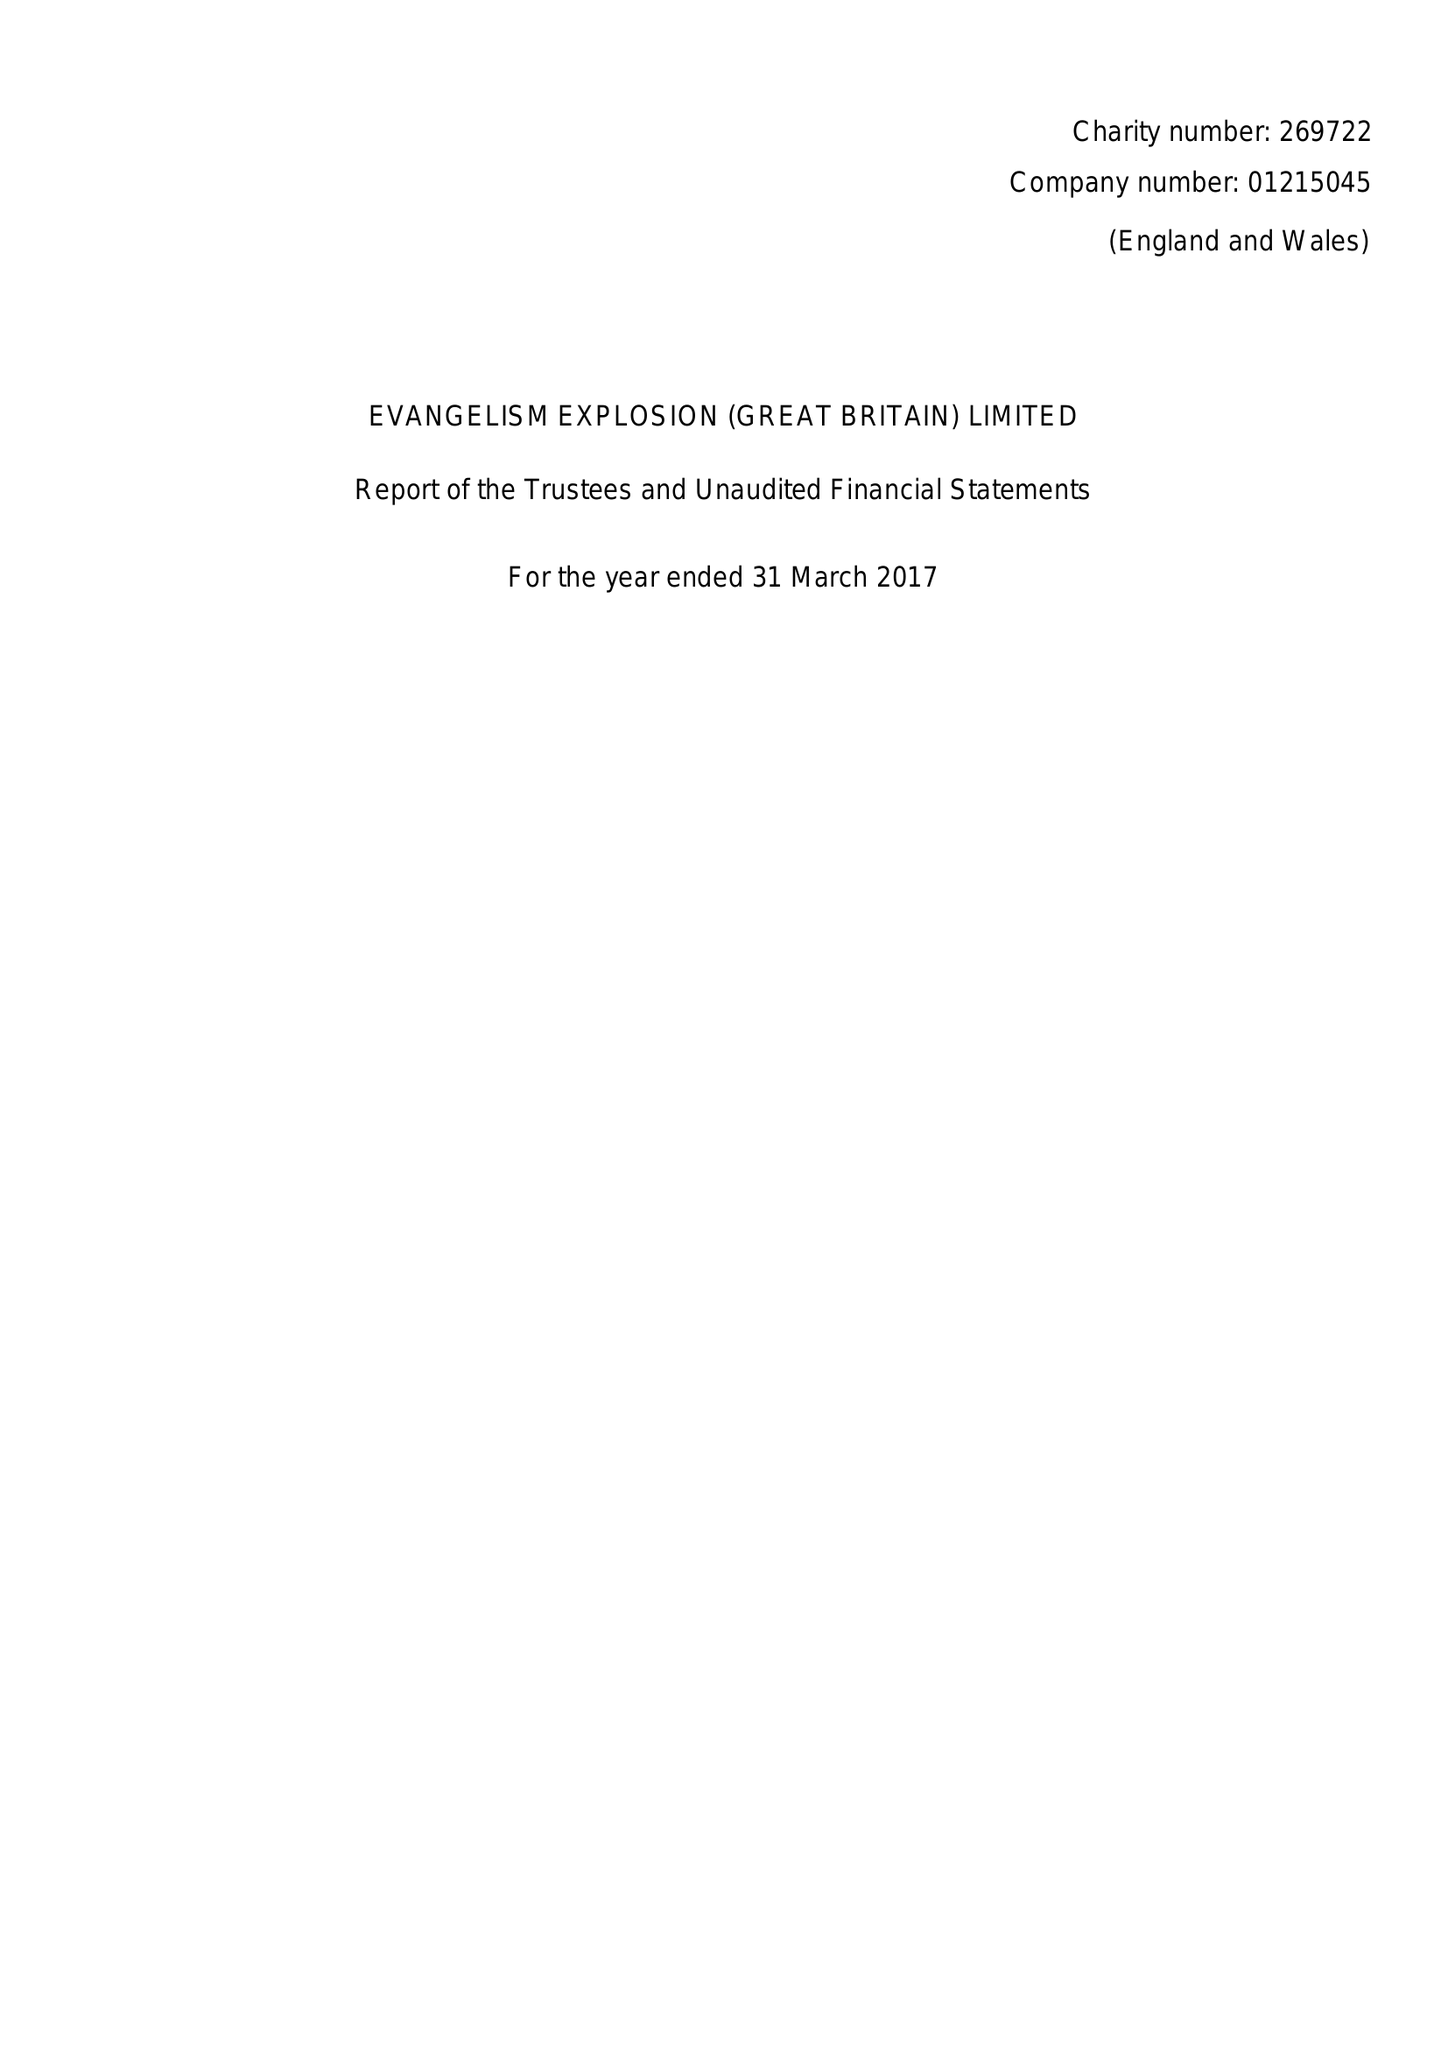What is the value for the address__post_town?
Answer the question using a single word or phrase. RUGBY 